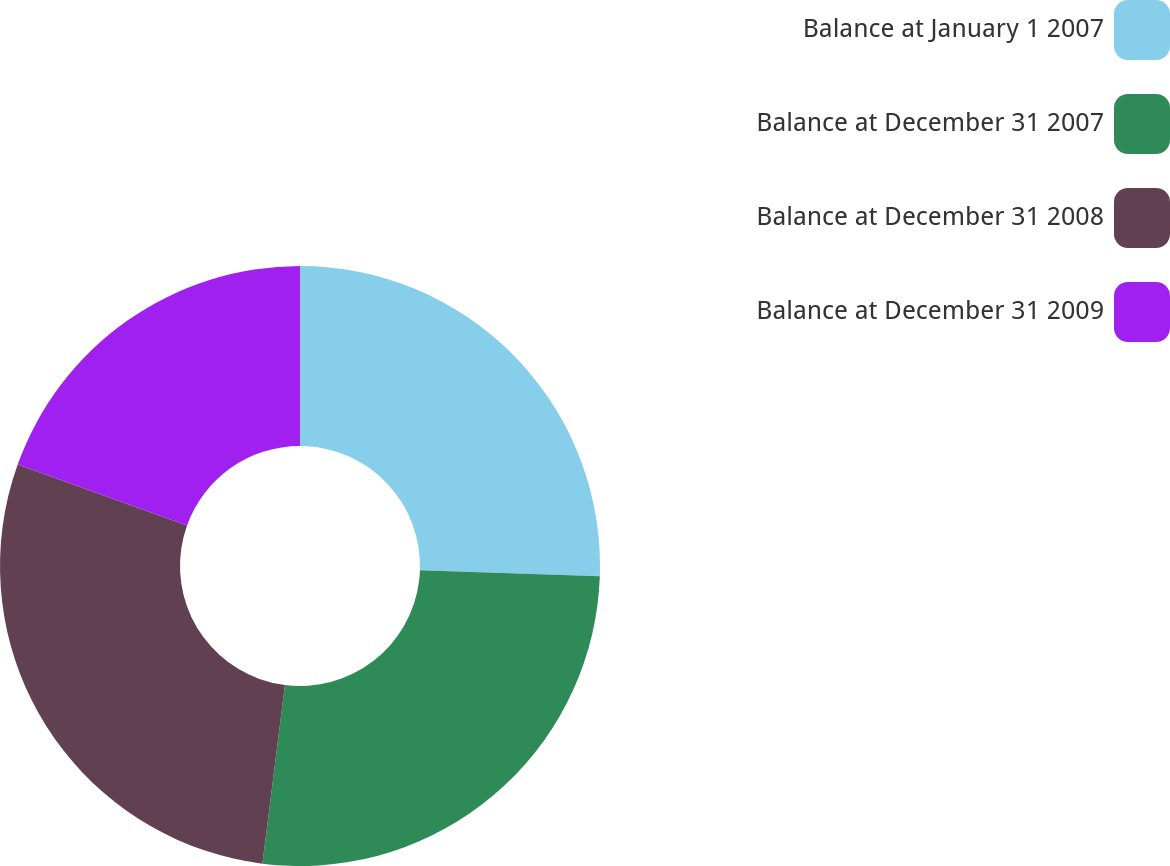<chart> <loc_0><loc_0><loc_500><loc_500><pie_chart><fcel>Balance at January 1 2007<fcel>Balance at December 31 2007<fcel>Balance at December 31 2008<fcel>Balance at December 31 2009<nl><fcel>25.55%<fcel>26.45%<fcel>28.49%<fcel>19.51%<nl></chart> 